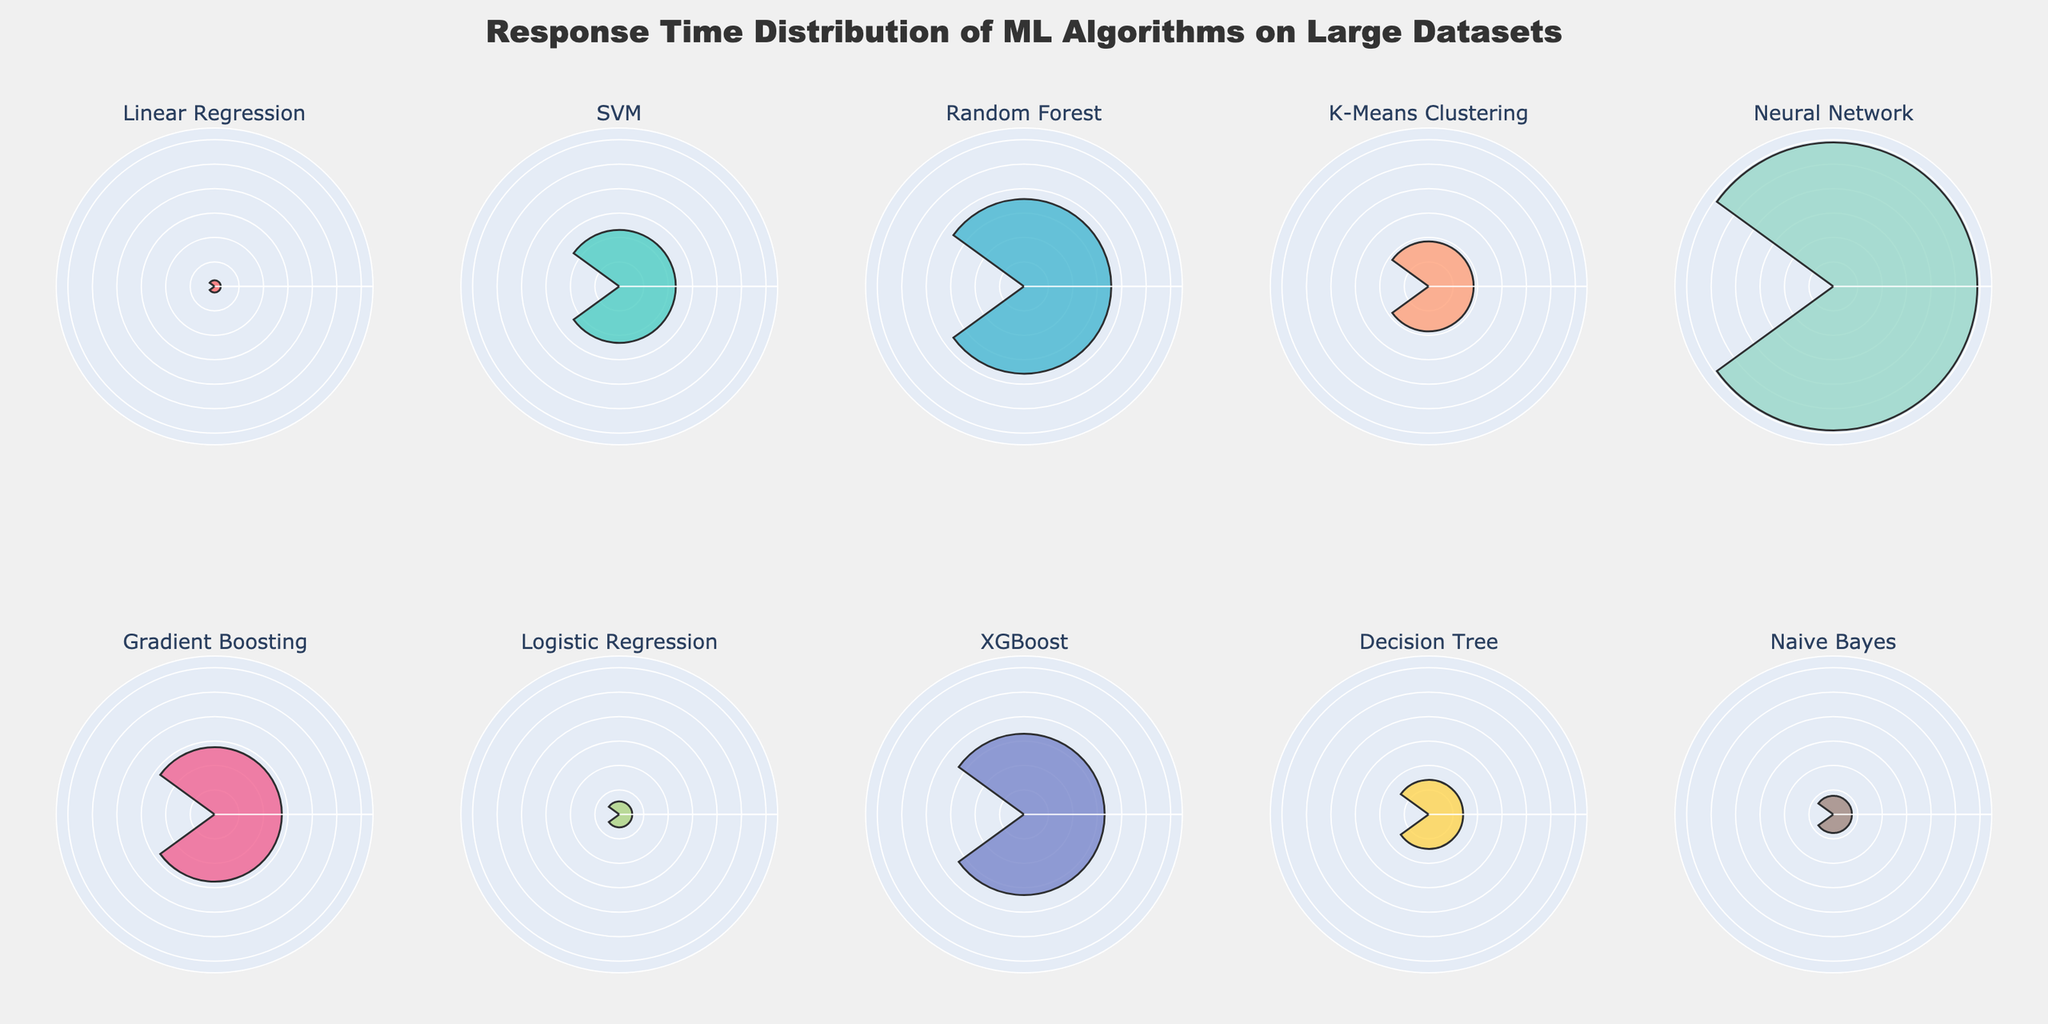What's the title of the figure? The title is located at the top of the figure and it serves as an overall description of what the subplot is about.
Answer: Response Time Distribution of ML Algorithms on Large Datasets How many algorithms are displayed in the rose charts? Each subplot has a different title, each corresponding to an algorithm. By counting these titles, we can determine the number of algorithms.
Answer: 10 Which algorithm has the highest response time? The heights of the bars in polar plots indicate the response time. By identifying the tallest bar, we can find the algorithm with the longest response time.
Answer: Neural Network Which algorithm has the lowest response time? Similar to finding the highest response time, locate the shortest bar in any of the polar plots to determine the algorithm with the shortest response time.
Answer: Linear Regression What is the response time for SVM on the Retail Product Sales dataset? By locating the subplot specific to SVM and reading the value associated with the bar's height, we find the response time.
Answer: 23.1 seconds How much longer does Gradient Boosting take compared to Logistic Regression? Identify the response times for Gradient Boosting and Logistic Regression, then subtract the latter from the former to find the difference.
Answer: 27.5 - 5.3 = 22.2 seconds Which algorithm is faster, Random Forest or XGBoost? Compare the heights of the bars for Random Forest and XGBoost. The shorter bar represents the faster algorithm.
Answer: Random Forest How many datasets are visualized in each subplot? Since each subplot represents the response time of an algorithm on one specific dataset, there is one dataset in each subplot.
Answer: 1 Among the algorithms with response times over 30 seconds, which dataset is used by the Neural Network? Identify all subplots with bars above 30 seconds to find the involved datasets, then locate the Neural Network subplot to determine its dataset.
Answer: Image Recognition (ImageNet) What is the average response time of all the algorithms combined? Sum all response times and divide by the total number of algorithms. (2.5 + 23.1 + 35.7 + 18.4 + 58.9 + 27.5 + 5.3 + 33.0 + 14.1 + 7.6) / 10 = 22.61
Answer: 22.61 seconds 